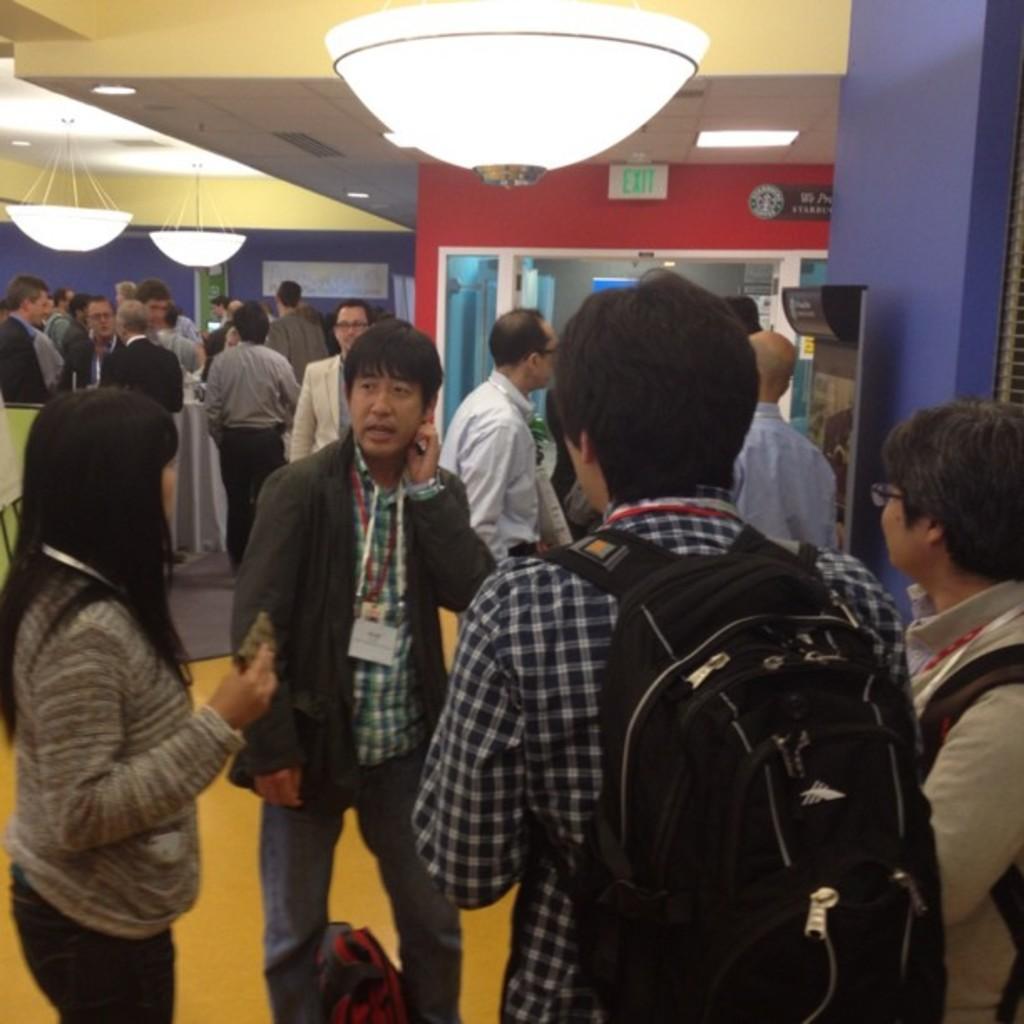Can you describe this image briefly? In this image we can see persons standing on the floor, sign board, chandeliers and electric lights. 